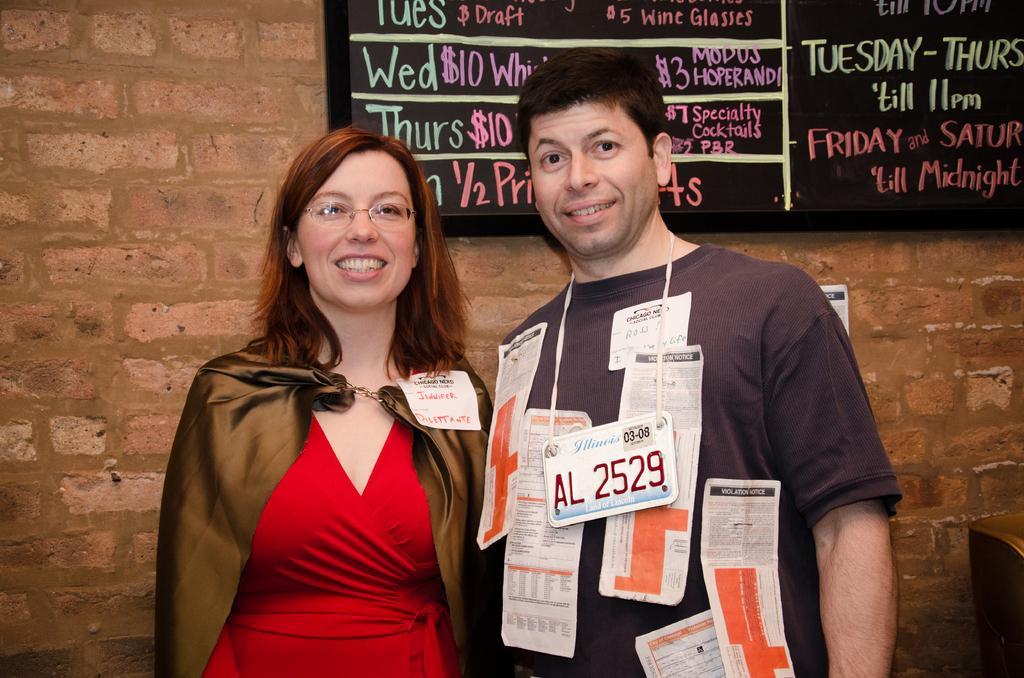Could you give a brief overview of what you see in this image? In this image, there are two persons standing with tags and papers and they are smiling. In the background, I can see a board attached to the wall. 